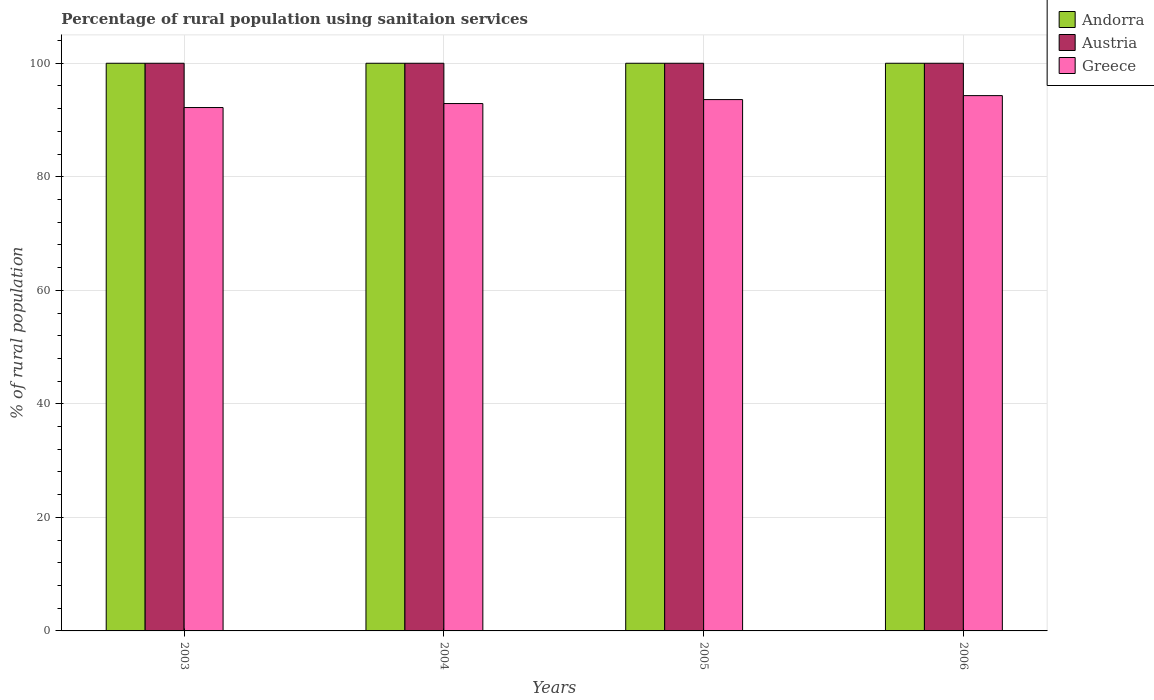How many groups of bars are there?
Your answer should be very brief. 4. Are the number of bars per tick equal to the number of legend labels?
Ensure brevity in your answer.  Yes. In how many cases, is the number of bars for a given year not equal to the number of legend labels?
Your answer should be very brief. 0. What is the percentage of rural population using sanitaion services in Andorra in 2004?
Make the answer very short. 100. Across all years, what is the maximum percentage of rural population using sanitaion services in Andorra?
Ensure brevity in your answer.  100. Across all years, what is the minimum percentage of rural population using sanitaion services in Greece?
Make the answer very short. 92.2. In which year was the percentage of rural population using sanitaion services in Greece minimum?
Your answer should be very brief. 2003. What is the total percentage of rural population using sanitaion services in Austria in the graph?
Give a very brief answer. 400. What is the difference between the percentage of rural population using sanitaion services in Greece in 2003 and that in 2004?
Give a very brief answer. -0.7. What is the difference between the percentage of rural population using sanitaion services in Greece in 2005 and the percentage of rural population using sanitaion services in Andorra in 2004?
Offer a very short reply. -6.4. In the year 2003, what is the difference between the percentage of rural population using sanitaion services in Greece and percentage of rural population using sanitaion services in Austria?
Provide a short and direct response. -7.8. In how many years, is the percentage of rural population using sanitaion services in Greece greater than 84 %?
Offer a very short reply. 4. What is the ratio of the percentage of rural population using sanitaion services in Austria in 2004 to that in 2006?
Provide a short and direct response. 1. Is the percentage of rural population using sanitaion services in Austria in 2004 less than that in 2005?
Provide a short and direct response. No. Is the difference between the percentage of rural population using sanitaion services in Greece in 2003 and 2005 greater than the difference between the percentage of rural population using sanitaion services in Austria in 2003 and 2005?
Ensure brevity in your answer.  No. What is the difference between the highest and the second highest percentage of rural population using sanitaion services in Greece?
Provide a succinct answer. 0.7. What is the difference between the highest and the lowest percentage of rural population using sanitaion services in Austria?
Provide a succinct answer. 0. What does the 1st bar from the left in 2004 represents?
Offer a terse response. Andorra. What does the 1st bar from the right in 2004 represents?
Ensure brevity in your answer.  Greece. How many bars are there?
Your answer should be very brief. 12. How many years are there in the graph?
Ensure brevity in your answer.  4. Are the values on the major ticks of Y-axis written in scientific E-notation?
Offer a very short reply. No. Where does the legend appear in the graph?
Your response must be concise. Top right. How are the legend labels stacked?
Provide a succinct answer. Vertical. What is the title of the graph?
Make the answer very short. Percentage of rural population using sanitaion services. What is the label or title of the X-axis?
Give a very brief answer. Years. What is the label or title of the Y-axis?
Provide a succinct answer. % of rural population. What is the % of rural population of Andorra in 2003?
Your answer should be compact. 100. What is the % of rural population of Greece in 2003?
Give a very brief answer. 92.2. What is the % of rural population of Greece in 2004?
Provide a succinct answer. 92.9. What is the % of rural population of Andorra in 2005?
Offer a very short reply. 100. What is the % of rural population in Austria in 2005?
Provide a succinct answer. 100. What is the % of rural population of Greece in 2005?
Offer a terse response. 93.6. What is the % of rural population in Andorra in 2006?
Offer a terse response. 100. What is the % of rural population of Greece in 2006?
Make the answer very short. 94.3. Across all years, what is the maximum % of rural population of Andorra?
Ensure brevity in your answer.  100. Across all years, what is the maximum % of rural population of Greece?
Your response must be concise. 94.3. Across all years, what is the minimum % of rural population of Andorra?
Offer a very short reply. 100. Across all years, what is the minimum % of rural population of Austria?
Give a very brief answer. 100. Across all years, what is the minimum % of rural population of Greece?
Provide a short and direct response. 92.2. What is the total % of rural population in Andorra in the graph?
Ensure brevity in your answer.  400. What is the total % of rural population of Greece in the graph?
Give a very brief answer. 373. What is the difference between the % of rural population in Andorra in 2003 and that in 2004?
Your response must be concise. 0. What is the difference between the % of rural population of Greece in 2003 and that in 2004?
Keep it short and to the point. -0.7. What is the difference between the % of rural population of Austria in 2004 and that in 2005?
Offer a very short reply. 0. What is the difference between the % of rural population in Greece in 2004 and that in 2005?
Your response must be concise. -0.7. What is the difference between the % of rural population in Andorra in 2004 and that in 2006?
Your answer should be very brief. 0. What is the difference between the % of rural population of Austria in 2004 and that in 2006?
Give a very brief answer. 0. What is the difference between the % of rural population in Austria in 2005 and that in 2006?
Your answer should be very brief. 0. What is the difference between the % of rural population of Andorra in 2003 and the % of rural population of Austria in 2004?
Offer a very short reply. 0. What is the difference between the % of rural population in Austria in 2003 and the % of rural population in Greece in 2004?
Keep it short and to the point. 7.1. What is the difference between the % of rural population of Andorra in 2003 and the % of rural population of Austria in 2005?
Offer a very short reply. 0. What is the difference between the % of rural population of Austria in 2003 and the % of rural population of Greece in 2005?
Your answer should be very brief. 6.4. What is the difference between the % of rural population in Andorra in 2003 and the % of rural population in Austria in 2006?
Provide a succinct answer. 0. What is the difference between the % of rural population of Andorra in 2003 and the % of rural population of Greece in 2006?
Your answer should be very brief. 5.7. What is the difference between the % of rural population of Andorra in 2004 and the % of rural population of Austria in 2005?
Provide a short and direct response. 0. What is the difference between the % of rural population in Andorra in 2004 and the % of rural population in Austria in 2006?
Make the answer very short. 0. What is the difference between the % of rural population of Austria in 2004 and the % of rural population of Greece in 2006?
Your response must be concise. 5.7. What is the difference between the % of rural population of Andorra in 2005 and the % of rural population of Greece in 2006?
Provide a succinct answer. 5.7. What is the average % of rural population in Andorra per year?
Your answer should be compact. 100. What is the average % of rural population of Austria per year?
Offer a terse response. 100. What is the average % of rural population in Greece per year?
Keep it short and to the point. 93.25. In the year 2003, what is the difference between the % of rural population of Andorra and % of rural population of Austria?
Your answer should be compact. 0. In the year 2003, what is the difference between the % of rural population of Andorra and % of rural population of Greece?
Make the answer very short. 7.8. In the year 2003, what is the difference between the % of rural population of Austria and % of rural population of Greece?
Offer a terse response. 7.8. In the year 2004, what is the difference between the % of rural population in Andorra and % of rural population in Austria?
Offer a terse response. 0. In the year 2004, what is the difference between the % of rural population of Austria and % of rural population of Greece?
Keep it short and to the point. 7.1. In the year 2005, what is the difference between the % of rural population in Andorra and % of rural population in Austria?
Make the answer very short. 0. In the year 2005, what is the difference between the % of rural population in Andorra and % of rural population in Greece?
Provide a short and direct response. 6.4. What is the ratio of the % of rural population in Andorra in 2003 to that in 2004?
Keep it short and to the point. 1. What is the ratio of the % of rural population in Austria in 2003 to that in 2005?
Offer a terse response. 1. What is the ratio of the % of rural population in Austria in 2003 to that in 2006?
Give a very brief answer. 1. What is the ratio of the % of rural population of Greece in 2003 to that in 2006?
Ensure brevity in your answer.  0.98. What is the ratio of the % of rural population of Andorra in 2004 to that in 2005?
Your response must be concise. 1. What is the ratio of the % of rural population of Austria in 2004 to that in 2005?
Your response must be concise. 1. What is the ratio of the % of rural population of Greece in 2004 to that in 2006?
Give a very brief answer. 0.99. What is the ratio of the % of rural population in Andorra in 2005 to that in 2006?
Ensure brevity in your answer.  1. What is the ratio of the % of rural population of Austria in 2005 to that in 2006?
Provide a short and direct response. 1. What is the ratio of the % of rural population of Greece in 2005 to that in 2006?
Offer a terse response. 0.99. What is the difference between the highest and the second highest % of rural population in Andorra?
Offer a terse response. 0. What is the difference between the highest and the second highest % of rural population of Greece?
Provide a succinct answer. 0.7. What is the difference between the highest and the lowest % of rural population in Andorra?
Ensure brevity in your answer.  0. What is the difference between the highest and the lowest % of rural population of Austria?
Your response must be concise. 0. 